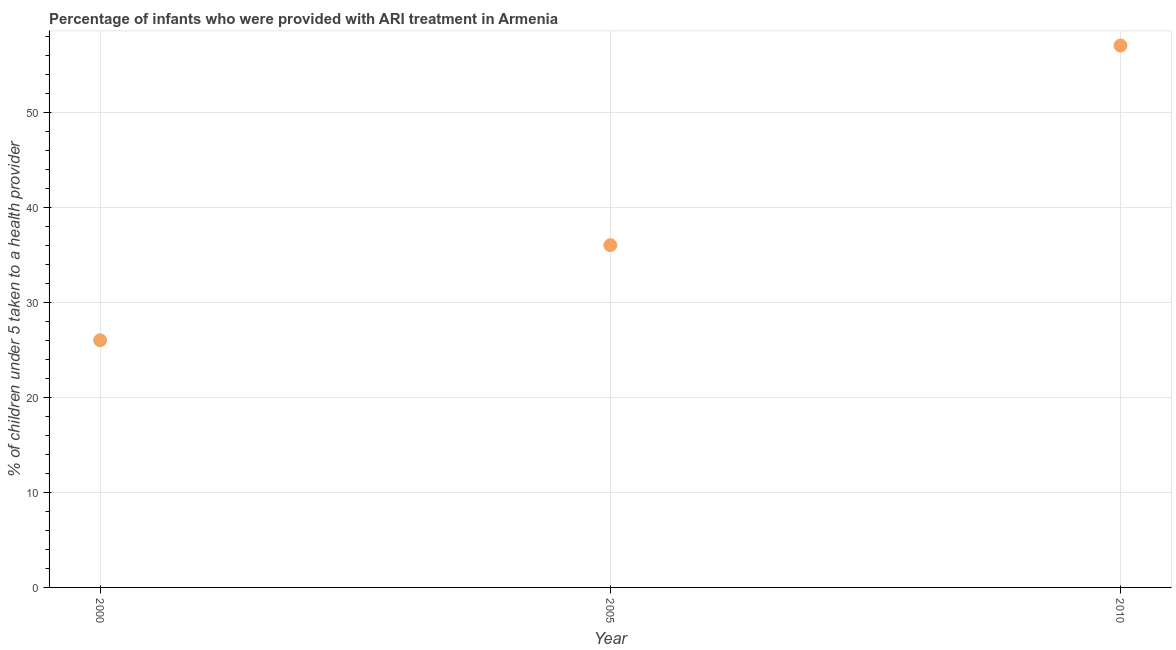What is the percentage of children who were provided with ari treatment in 2010?
Your answer should be compact. 57. Across all years, what is the maximum percentage of children who were provided with ari treatment?
Keep it short and to the point. 57. Across all years, what is the minimum percentage of children who were provided with ari treatment?
Provide a short and direct response. 26. In which year was the percentage of children who were provided with ari treatment minimum?
Provide a succinct answer. 2000. What is the sum of the percentage of children who were provided with ari treatment?
Offer a very short reply. 119. What is the difference between the percentage of children who were provided with ari treatment in 2000 and 2005?
Your response must be concise. -10. What is the average percentage of children who were provided with ari treatment per year?
Provide a short and direct response. 39.67. In how many years, is the percentage of children who were provided with ari treatment greater than 12 %?
Provide a succinct answer. 3. What is the ratio of the percentage of children who were provided with ari treatment in 2005 to that in 2010?
Make the answer very short. 0.63. Is the percentage of children who were provided with ari treatment in 2000 less than that in 2010?
Ensure brevity in your answer.  Yes. What is the difference between the highest and the lowest percentage of children who were provided with ari treatment?
Offer a terse response. 31. How many years are there in the graph?
Your response must be concise. 3. Does the graph contain grids?
Offer a very short reply. Yes. What is the title of the graph?
Provide a short and direct response. Percentage of infants who were provided with ARI treatment in Armenia. What is the label or title of the X-axis?
Offer a terse response. Year. What is the label or title of the Y-axis?
Provide a succinct answer. % of children under 5 taken to a health provider. What is the % of children under 5 taken to a health provider in 2000?
Provide a succinct answer. 26. What is the % of children under 5 taken to a health provider in 2005?
Provide a succinct answer. 36. What is the difference between the % of children under 5 taken to a health provider in 2000 and 2005?
Make the answer very short. -10. What is the difference between the % of children under 5 taken to a health provider in 2000 and 2010?
Keep it short and to the point. -31. What is the difference between the % of children under 5 taken to a health provider in 2005 and 2010?
Ensure brevity in your answer.  -21. What is the ratio of the % of children under 5 taken to a health provider in 2000 to that in 2005?
Your answer should be compact. 0.72. What is the ratio of the % of children under 5 taken to a health provider in 2000 to that in 2010?
Offer a terse response. 0.46. What is the ratio of the % of children under 5 taken to a health provider in 2005 to that in 2010?
Your response must be concise. 0.63. 